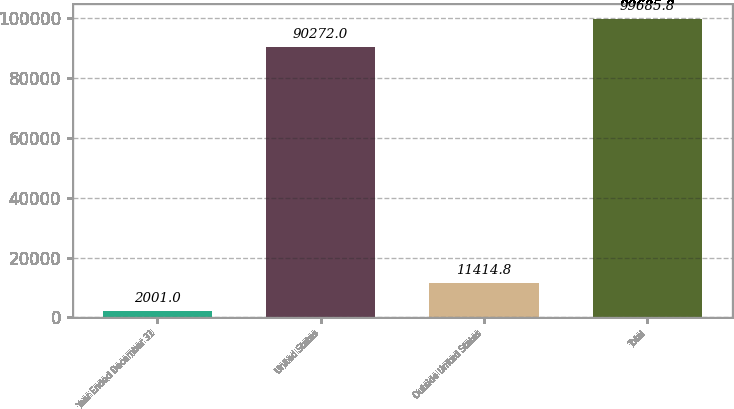<chart> <loc_0><loc_0><loc_500><loc_500><bar_chart><fcel>Year Ended December 31<fcel>United States<fcel>Outside United States<fcel>Total<nl><fcel>2001<fcel>90272<fcel>11414.8<fcel>99685.8<nl></chart> 